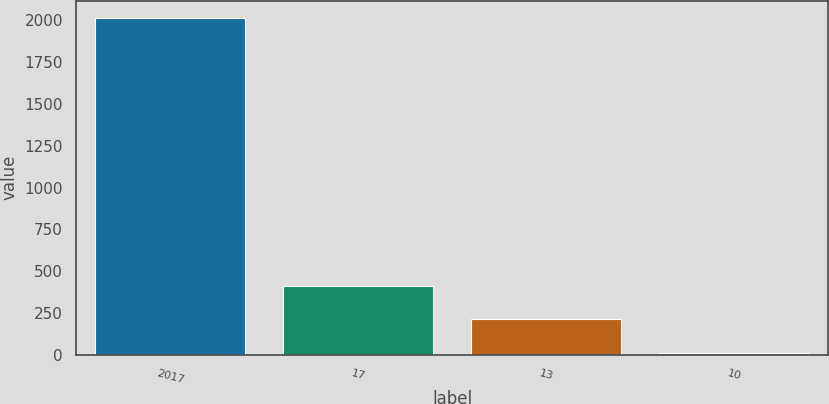<chart> <loc_0><loc_0><loc_500><loc_500><bar_chart><fcel>2017<fcel>17<fcel>13<fcel>10<nl><fcel>2016<fcel>411.2<fcel>210.6<fcel>10<nl></chart> 